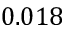Convert formula to latex. <formula><loc_0><loc_0><loc_500><loc_500>0 . 0 1 8</formula> 